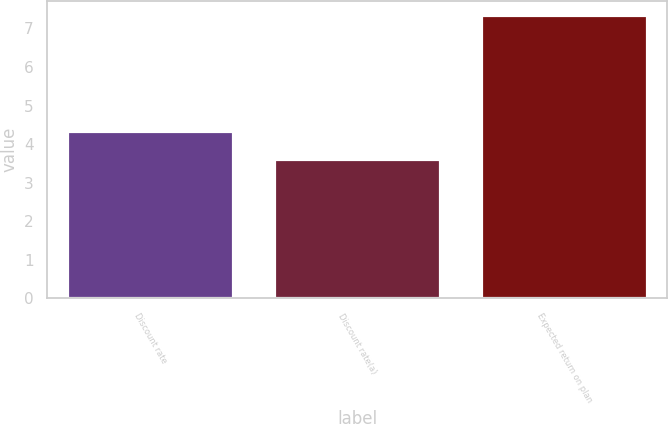Convert chart. <chart><loc_0><loc_0><loc_500><loc_500><bar_chart><fcel>Discount rate<fcel>Discount rate(a)<fcel>Expected return on plan<nl><fcel>4.34<fcel>3.62<fcel>7.35<nl></chart> 